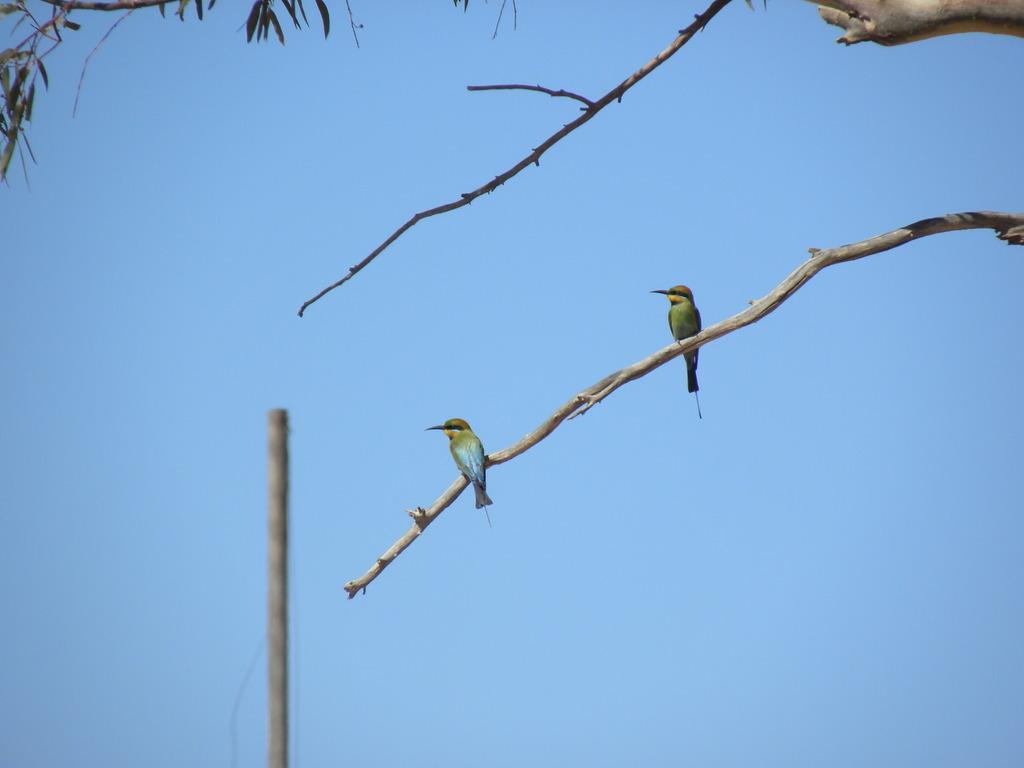How would you summarize this image in a sentence or two? In the center of the image we can see branches with leaves. On one of the branches, we can see two birds. In the background, we can see the sky and a pole. 